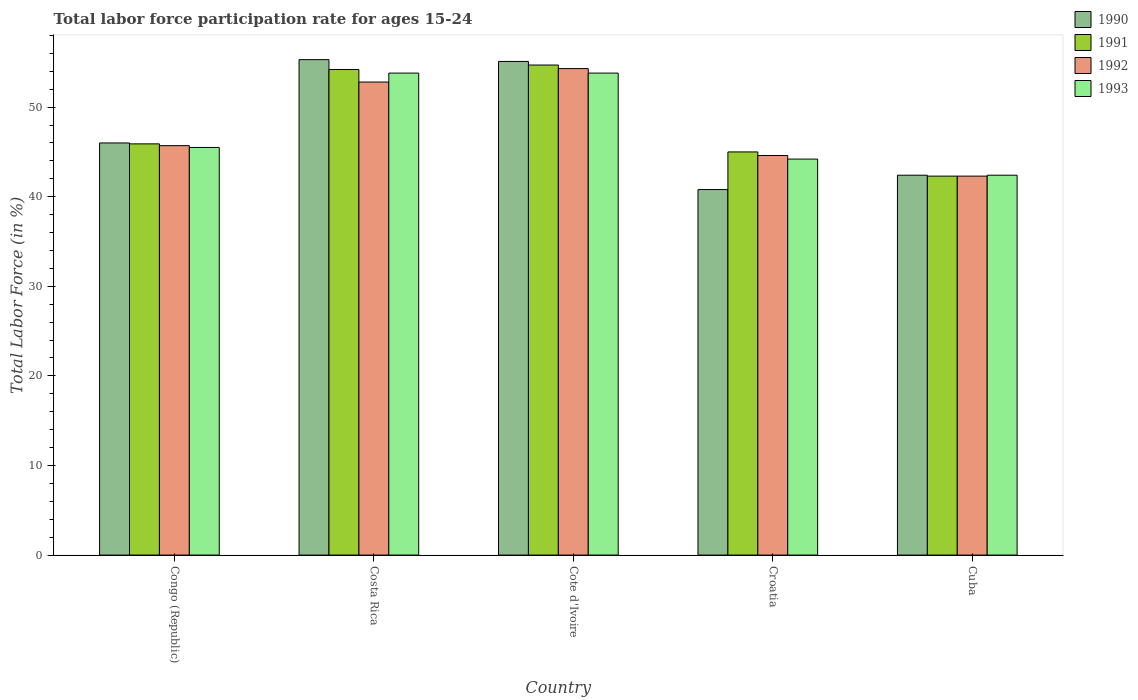How many different coloured bars are there?
Offer a terse response. 4. What is the label of the 4th group of bars from the left?
Give a very brief answer. Croatia. In how many cases, is the number of bars for a given country not equal to the number of legend labels?
Make the answer very short. 0. What is the labor force participation rate in 1991 in Cuba?
Offer a terse response. 42.3. Across all countries, what is the maximum labor force participation rate in 1990?
Offer a very short reply. 55.3. Across all countries, what is the minimum labor force participation rate in 1993?
Ensure brevity in your answer.  42.4. In which country was the labor force participation rate in 1992 maximum?
Keep it short and to the point. Cote d'Ivoire. In which country was the labor force participation rate in 1991 minimum?
Ensure brevity in your answer.  Cuba. What is the total labor force participation rate in 1991 in the graph?
Make the answer very short. 242.1. What is the difference between the labor force participation rate in 1993 in Cote d'Ivoire and that in Cuba?
Ensure brevity in your answer.  11.4. What is the difference between the labor force participation rate in 1990 in Croatia and the labor force participation rate in 1993 in Cote d'Ivoire?
Offer a terse response. -13. What is the average labor force participation rate in 1993 per country?
Keep it short and to the point. 47.94. What is the difference between the labor force participation rate of/in 1991 and labor force participation rate of/in 1990 in Cote d'Ivoire?
Provide a short and direct response. -0.4. In how many countries, is the labor force participation rate in 1993 greater than 34 %?
Keep it short and to the point. 5. What is the ratio of the labor force participation rate in 1993 in Congo (Republic) to that in Cuba?
Offer a terse response. 1.07. Is the difference between the labor force participation rate in 1991 in Congo (Republic) and Costa Rica greater than the difference between the labor force participation rate in 1990 in Congo (Republic) and Costa Rica?
Your response must be concise. Yes. What is the difference between the highest and the second highest labor force participation rate in 1990?
Offer a very short reply. 9.1. What is the difference between the highest and the lowest labor force participation rate in 1993?
Make the answer very short. 11.4. Is it the case that in every country, the sum of the labor force participation rate in 1991 and labor force participation rate in 1993 is greater than the sum of labor force participation rate in 1990 and labor force participation rate in 1992?
Ensure brevity in your answer.  No. What does the 3rd bar from the left in Costa Rica represents?
Provide a short and direct response. 1992. How many bars are there?
Offer a terse response. 20. What is the difference between two consecutive major ticks on the Y-axis?
Offer a terse response. 10. Are the values on the major ticks of Y-axis written in scientific E-notation?
Your answer should be compact. No. Does the graph contain any zero values?
Offer a very short reply. No. Where does the legend appear in the graph?
Make the answer very short. Top right. How many legend labels are there?
Your answer should be compact. 4. How are the legend labels stacked?
Offer a terse response. Vertical. What is the title of the graph?
Offer a very short reply. Total labor force participation rate for ages 15-24. Does "1981" appear as one of the legend labels in the graph?
Make the answer very short. No. What is the label or title of the X-axis?
Ensure brevity in your answer.  Country. What is the Total Labor Force (in %) of 1990 in Congo (Republic)?
Your answer should be very brief. 46. What is the Total Labor Force (in %) of 1991 in Congo (Republic)?
Your answer should be compact. 45.9. What is the Total Labor Force (in %) of 1992 in Congo (Republic)?
Offer a very short reply. 45.7. What is the Total Labor Force (in %) of 1993 in Congo (Republic)?
Your response must be concise. 45.5. What is the Total Labor Force (in %) of 1990 in Costa Rica?
Ensure brevity in your answer.  55.3. What is the Total Labor Force (in %) of 1991 in Costa Rica?
Offer a very short reply. 54.2. What is the Total Labor Force (in %) in 1992 in Costa Rica?
Your answer should be very brief. 52.8. What is the Total Labor Force (in %) of 1993 in Costa Rica?
Your response must be concise. 53.8. What is the Total Labor Force (in %) in 1990 in Cote d'Ivoire?
Offer a very short reply. 55.1. What is the Total Labor Force (in %) of 1991 in Cote d'Ivoire?
Keep it short and to the point. 54.7. What is the Total Labor Force (in %) in 1992 in Cote d'Ivoire?
Make the answer very short. 54.3. What is the Total Labor Force (in %) of 1993 in Cote d'Ivoire?
Give a very brief answer. 53.8. What is the Total Labor Force (in %) in 1990 in Croatia?
Make the answer very short. 40.8. What is the Total Labor Force (in %) in 1992 in Croatia?
Make the answer very short. 44.6. What is the Total Labor Force (in %) in 1993 in Croatia?
Your answer should be compact. 44.2. What is the Total Labor Force (in %) of 1990 in Cuba?
Give a very brief answer. 42.4. What is the Total Labor Force (in %) of 1991 in Cuba?
Make the answer very short. 42.3. What is the Total Labor Force (in %) of 1992 in Cuba?
Ensure brevity in your answer.  42.3. What is the Total Labor Force (in %) of 1993 in Cuba?
Provide a short and direct response. 42.4. Across all countries, what is the maximum Total Labor Force (in %) in 1990?
Your answer should be compact. 55.3. Across all countries, what is the maximum Total Labor Force (in %) in 1991?
Your answer should be compact. 54.7. Across all countries, what is the maximum Total Labor Force (in %) of 1992?
Your answer should be very brief. 54.3. Across all countries, what is the maximum Total Labor Force (in %) of 1993?
Your answer should be very brief. 53.8. Across all countries, what is the minimum Total Labor Force (in %) of 1990?
Offer a terse response. 40.8. Across all countries, what is the minimum Total Labor Force (in %) of 1991?
Provide a succinct answer. 42.3. Across all countries, what is the minimum Total Labor Force (in %) in 1992?
Provide a succinct answer. 42.3. Across all countries, what is the minimum Total Labor Force (in %) in 1993?
Provide a short and direct response. 42.4. What is the total Total Labor Force (in %) in 1990 in the graph?
Ensure brevity in your answer.  239.6. What is the total Total Labor Force (in %) of 1991 in the graph?
Provide a succinct answer. 242.1. What is the total Total Labor Force (in %) in 1992 in the graph?
Give a very brief answer. 239.7. What is the total Total Labor Force (in %) of 1993 in the graph?
Keep it short and to the point. 239.7. What is the difference between the Total Labor Force (in %) in 1990 in Congo (Republic) and that in Costa Rica?
Your response must be concise. -9.3. What is the difference between the Total Labor Force (in %) in 1991 in Congo (Republic) and that in Costa Rica?
Make the answer very short. -8.3. What is the difference between the Total Labor Force (in %) of 1992 in Congo (Republic) and that in Costa Rica?
Offer a terse response. -7.1. What is the difference between the Total Labor Force (in %) of 1992 in Congo (Republic) and that in Cote d'Ivoire?
Your response must be concise. -8.6. What is the difference between the Total Labor Force (in %) of 1991 in Congo (Republic) and that in Croatia?
Make the answer very short. 0.9. What is the difference between the Total Labor Force (in %) in 1991 in Congo (Republic) and that in Cuba?
Your answer should be very brief. 3.6. What is the difference between the Total Labor Force (in %) of 1990 in Costa Rica and that in Cote d'Ivoire?
Keep it short and to the point. 0.2. What is the difference between the Total Labor Force (in %) of 1992 in Costa Rica and that in Cote d'Ivoire?
Provide a succinct answer. -1.5. What is the difference between the Total Labor Force (in %) in 1993 in Costa Rica and that in Cote d'Ivoire?
Offer a terse response. 0. What is the difference between the Total Labor Force (in %) of 1991 in Costa Rica and that in Croatia?
Your response must be concise. 9.2. What is the difference between the Total Labor Force (in %) in 1992 in Costa Rica and that in Croatia?
Make the answer very short. 8.2. What is the difference between the Total Labor Force (in %) in 1991 in Cote d'Ivoire and that in Cuba?
Your response must be concise. 12.4. What is the difference between the Total Labor Force (in %) of 1993 in Cote d'Ivoire and that in Cuba?
Your response must be concise. 11.4. What is the difference between the Total Labor Force (in %) of 1990 in Croatia and that in Cuba?
Your response must be concise. -1.6. What is the difference between the Total Labor Force (in %) of 1991 in Croatia and that in Cuba?
Your response must be concise. 2.7. What is the difference between the Total Labor Force (in %) in 1992 in Croatia and that in Cuba?
Give a very brief answer. 2.3. What is the difference between the Total Labor Force (in %) of 1993 in Croatia and that in Cuba?
Provide a short and direct response. 1.8. What is the difference between the Total Labor Force (in %) in 1990 in Congo (Republic) and the Total Labor Force (in %) in 1992 in Costa Rica?
Provide a short and direct response. -6.8. What is the difference between the Total Labor Force (in %) of 1992 in Congo (Republic) and the Total Labor Force (in %) of 1993 in Costa Rica?
Provide a succinct answer. -8.1. What is the difference between the Total Labor Force (in %) in 1990 in Congo (Republic) and the Total Labor Force (in %) in 1992 in Cote d'Ivoire?
Your answer should be very brief. -8.3. What is the difference between the Total Labor Force (in %) of 1991 in Congo (Republic) and the Total Labor Force (in %) of 1992 in Cote d'Ivoire?
Ensure brevity in your answer.  -8.4. What is the difference between the Total Labor Force (in %) in 1991 in Congo (Republic) and the Total Labor Force (in %) in 1993 in Cote d'Ivoire?
Offer a very short reply. -7.9. What is the difference between the Total Labor Force (in %) in 1991 in Congo (Republic) and the Total Labor Force (in %) in 1992 in Croatia?
Offer a terse response. 1.3. What is the difference between the Total Labor Force (in %) of 1991 in Congo (Republic) and the Total Labor Force (in %) of 1993 in Croatia?
Your response must be concise. 1.7. What is the difference between the Total Labor Force (in %) in 1990 in Congo (Republic) and the Total Labor Force (in %) in 1993 in Cuba?
Give a very brief answer. 3.6. What is the difference between the Total Labor Force (in %) in 1991 in Congo (Republic) and the Total Labor Force (in %) in 1993 in Cuba?
Provide a short and direct response. 3.5. What is the difference between the Total Labor Force (in %) of 1990 in Costa Rica and the Total Labor Force (in %) of 1991 in Cote d'Ivoire?
Offer a terse response. 0.6. What is the difference between the Total Labor Force (in %) in 1992 in Costa Rica and the Total Labor Force (in %) in 1993 in Cote d'Ivoire?
Offer a terse response. -1. What is the difference between the Total Labor Force (in %) of 1991 in Costa Rica and the Total Labor Force (in %) of 1992 in Croatia?
Keep it short and to the point. 9.6. What is the difference between the Total Labor Force (in %) of 1992 in Costa Rica and the Total Labor Force (in %) of 1993 in Croatia?
Your response must be concise. 8.6. What is the difference between the Total Labor Force (in %) in 1991 in Costa Rica and the Total Labor Force (in %) in 1993 in Cuba?
Make the answer very short. 11.8. What is the difference between the Total Labor Force (in %) in 1990 in Cote d'Ivoire and the Total Labor Force (in %) in 1991 in Croatia?
Keep it short and to the point. 10.1. What is the difference between the Total Labor Force (in %) in 1991 in Cote d'Ivoire and the Total Labor Force (in %) in 1993 in Croatia?
Ensure brevity in your answer.  10.5. What is the difference between the Total Labor Force (in %) in 1992 in Cote d'Ivoire and the Total Labor Force (in %) in 1993 in Croatia?
Make the answer very short. 10.1. What is the difference between the Total Labor Force (in %) of 1990 in Cote d'Ivoire and the Total Labor Force (in %) of 1992 in Cuba?
Your answer should be very brief. 12.8. What is the difference between the Total Labor Force (in %) in 1990 in Cote d'Ivoire and the Total Labor Force (in %) in 1993 in Cuba?
Your answer should be very brief. 12.7. What is the difference between the Total Labor Force (in %) in 1992 in Cote d'Ivoire and the Total Labor Force (in %) in 1993 in Cuba?
Keep it short and to the point. 11.9. What is the difference between the Total Labor Force (in %) in 1990 in Croatia and the Total Labor Force (in %) in 1991 in Cuba?
Offer a terse response. -1.5. What is the difference between the Total Labor Force (in %) of 1990 in Croatia and the Total Labor Force (in %) of 1992 in Cuba?
Your response must be concise. -1.5. What is the difference between the Total Labor Force (in %) in 1991 in Croatia and the Total Labor Force (in %) in 1992 in Cuba?
Offer a terse response. 2.7. What is the difference between the Total Labor Force (in %) in 1992 in Croatia and the Total Labor Force (in %) in 1993 in Cuba?
Offer a terse response. 2.2. What is the average Total Labor Force (in %) in 1990 per country?
Provide a short and direct response. 47.92. What is the average Total Labor Force (in %) of 1991 per country?
Provide a short and direct response. 48.42. What is the average Total Labor Force (in %) of 1992 per country?
Ensure brevity in your answer.  47.94. What is the average Total Labor Force (in %) of 1993 per country?
Your answer should be compact. 47.94. What is the difference between the Total Labor Force (in %) in 1990 and Total Labor Force (in %) in 1991 in Congo (Republic)?
Your response must be concise. 0.1. What is the difference between the Total Labor Force (in %) in 1990 and Total Labor Force (in %) in 1992 in Congo (Republic)?
Make the answer very short. 0.3. What is the difference between the Total Labor Force (in %) of 1992 and Total Labor Force (in %) of 1993 in Congo (Republic)?
Your answer should be very brief. 0.2. What is the difference between the Total Labor Force (in %) in 1990 and Total Labor Force (in %) in 1991 in Costa Rica?
Keep it short and to the point. 1.1. What is the difference between the Total Labor Force (in %) of 1991 and Total Labor Force (in %) of 1992 in Costa Rica?
Offer a terse response. 1.4. What is the difference between the Total Labor Force (in %) in 1990 and Total Labor Force (in %) in 1991 in Cote d'Ivoire?
Your answer should be compact. 0.4. What is the difference between the Total Labor Force (in %) of 1990 and Total Labor Force (in %) of 1993 in Cote d'Ivoire?
Your answer should be very brief. 1.3. What is the difference between the Total Labor Force (in %) in 1992 and Total Labor Force (in %) in 1993 in Cote d'Ivoire?
Give a very brief answer. 0.5. What is the difference between the Total Labor Force (in %) of 1990 and Total Labor Force (in %) of 1991 in Croatia?
Give a very brief answer. -4.2. What is the difference between the Total Labor Force (in %) of 1990 and Total Labor Force (in %) of 1992 in Croatia?
Offer a very short reply. -3.8. What is the difference between the Total Labor Force (in %) of 1991 and Total Labor Force (in %) of 1993 in Croatia?
Offer a terse response. 0.8. What is the difference between the Total Labor Force (in %) of 1992 and Total Labor Force (in %) of 1993 in Croatia?
Ensure brevity in your answer.  0.4. What is the difference between the Total Labor Force (in %) of 1990 and Total Labor Force (in %) of 1992 in Cuba?
Give a very brief answer. 0.1. What is the difference between the Total Labor Force (in %) in 1991 and Total Labor Force (in %) in 1993 in Cuba?
Offer a very short reply. -0.1. What is the ratio of the Total Labor Force (in %) in 1990 in Congo (Republic) to that in Costa Rica?
Ensure brevity in your answer.  0.83. What is the ratio of the Total Labor Force (in %) of 1991 in Congo (Republic) to that in Costa Rica?
Make the answer very short. 0.85. What is the ratio of the Total Labor Force (in %) in 1992 in Congo (Republic) to that in Costa Rica?
Your answer should be compact. 0.87. What is the ratio of the Total Labor Force (in %) in 1993 in Congo (Republic) to that in Costa Rica?
Provide a succinct answer. 0.85. What is the ratio of the Total Labor Force (in %) of 1990 in Congo (Republic) to that in Cote d'Ivoire?
Give a very brief answer. 0.83. What is the ratio of the Total Labor Force (in %) in 1991 in Congo (Republic) to that in Cote d'Ivoire?
Ensure brevity in your answer.  0.84. What is the ratio of the Total Labor Force (in %) in 1992 in Congo (Republic) to that in Cote d'Ivoire?
Give a very brief answer. 0.84. What is the ratio of the Total Labor Force (in %) of 1993 in Congo (Republic) to that in Cote d'Ivoire?
Your response must be concise. 0.85. What is the ratio of the Total Labor Force (in %) of 1990 in Congo (Republic) to that in Croatia?
Make the answer very short. 1.13. What is the ratio of the Total Labor Force (in %) in 1991 in Congo (Republic) to that in Croatia?
Ensure brevity in your answer.  1.02. What is the ratio of the Total Labor Force (in %) in 1992 in Congo (Republic) to that in Croatia?
Offer a very short reply. 1.02. What is the ratio of the Total Labor Force (in %) in 1993 in Congo (Republic) to that in Croatia?
Keep it short and to the point. 1.03. What is the ratio of the Total Labor Force (in %) in 1990 in Congo (Republic) to that in Cuba?
Ensure brevity in your answer.  1.08. What is the ratio of the Total Labor Force (in %) in 1991 in Congo (Republic) to that in Cuba?
Give a very brief answer. 1.09. What is the ratio of the Total Labor Force (in %) of 1992 in Congo (Republic) to that in Cuba?
Provide a succinct answer. 1.08. What is the ratio of the Total Labor Force (in %) in 1993 in Congo (Republic) to that in Cuba?
Provide a succinct answer. 1.07. What is the ratio of the Total Labor Force (in %) in 1990 in Costa Rica to that in Cote d'Ivoire?
Offer a terse response. 1. What is the ratio of the Total Labor Force (in %) in 1991 in Costa Rica to that in Cote d'Ivoire?
Make the answer very short. 0.99. What is the ratio of the Total Labor Force (in %) in 1992 in Costa Rica to that in Cote d'Ivoire?
Provide a succinct answer. 0.97. What is the ratio of the Total Labor Force (in %) in 1990 in Costa Rica to that in Croatia?
Give a very brief answer. 1.36. What is the ratio of the Total Labor Force (in %) of 1991 in Costa Rica to that in Croatia?
Your answer should be compact. 1.2. What is the ratio of the Total Labor Force (in %) of 1992 in Costa Rica to that in Croatia?
Provide a succinct answer. 1.18. What is the ratio of the Total Labor Force (in %) of 1993 in Costa Rica to that in Croatia?
Give a very brief answer. 1.22. What is the ratio of the Total Labor Force (in %) in 1990 in Costa Rica to that in Cuba?
Keep it short and to the point. 1.3. What is the ratio of the Total Labor Force (in %) of 1991 in Costa Rica to that in Cuba?
Make the answer very short. 1.28. What is the ratio of the Total Labor Force (in %) in 1992 in Costa Rica to that in Cuba?
Offer a very short reply. 1.25. What is the ratio of the Total Labor Force (in %) of 1993 in Costa Rica to that in Cuba?
Offer a terse response. 1.27. What is the ratio of the Total Labor Force (in %) of 1990 in Cote d'Ivoire to that in Croatia?
Provide a succinct answer. 1.35. What is the ratio of the Total Labor Force (in %) of 1991 in Cote d'Ivoire to that in Croatia?
Give a very brief answer. 1.22. What is the ratio of the Total Labor Force (in %) of 1992 in Cote d'Ivoire to that in Croatia?
Your response must be concise. 1.22. What is the ratio of the Total Labor Force (in %) of 1993 in Cote d'Ivoire to that in Croatia?
Your response must be concise. 1.22. What is the ratio of the Total Labor Force (in %) in 1990 in Cote d'Ivoire to that in Cuba?
Offer a terse response. 1.3. What is the ratio of the Total Labor Force (in %) in 1991 in Cote d'Ivoire to that in Cuba?
Give a very brief answer. 1.29. What is the ratio of the Total Labor Force (in %) of 1992 in Cote d'Ivoire to that in Cuba?
Your response must be concise. 1.28. What is the ratio of the Total Labor Force (in %) in 1993 in Cote d'Ivoire to that in Cuba?
Your answer should be compact. 1.27. What is the ratio of the Total Labor Force (in %) in 1990 in Croatia to that in Cuba?
Offer a very short reply. 0.96. What is the ratio of the Total Labor Force (in %) of 1991 in Croatia to that in Cuba?
Give a very brief answer. 1.06. What is the ratio of the Total Labor Force (in %) in 1992 in Croatia to that in Cuba?
Make the answer very short. 1.05. What is the ratio of the Total Labor Force (in %) in 1993 in Croatia to that in Cuba?
Offer a terse response. 1.04. What is the difference between the highest and the second highest Total Labor Force (in %) in 1990?
Give a very brief answer. 0.2. What is the difference between the highest and the second highest Total Labor Force (in %) in 1991?
Offer a terse response. 0.5. What is the difference between the highest and the second highest Total Labor Force (in %) in 1992?
Your response must be concise. 1.5. What is the difference between the highest and the second highest Total Labor Force (in %) of 1993?
Your response must be concise. 0. What is the difference between the highest and the lowest Total Labor Force (in %) in 1990?
Provide a succinct answer. 14.5. What is the difference between the highest and the lowest Total Labor Force (in %) of 1993?
Offer a very short reply. 11.4. 